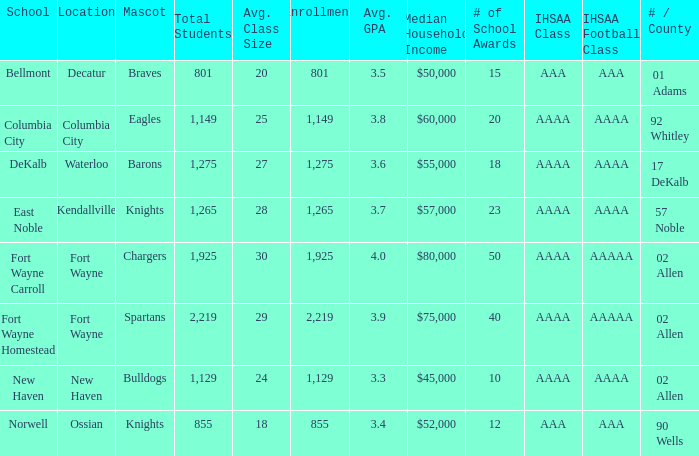What school has a mascot of the spartans with an AAAA IHSAA class and more than 1,275 enrolled? Fort Wayne Homestead. 